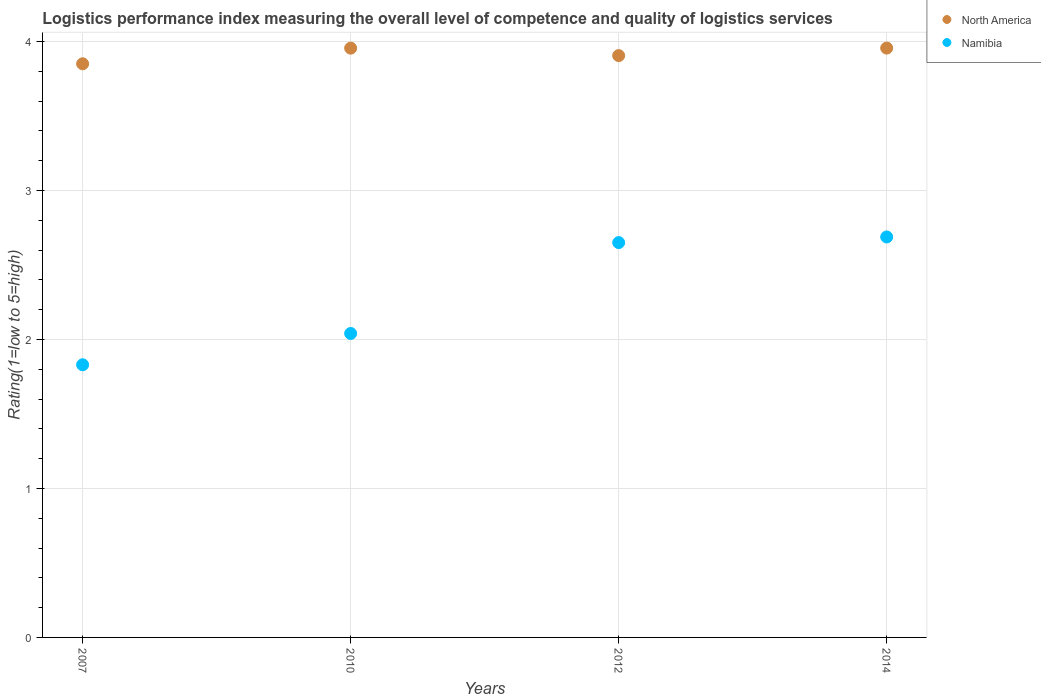What is the Logistic performance index in Namibia in 2012?
Your response must be concise. 2.65. Across all years, what is the maximum Logistic performance index in Namibia?
Make the answer very short. 2.69. Across all years, what is the minimum Logistic performance index in North America?
Offer a terse response. 3.85. What is the total Logistic performance index in Namibia in the graph?
Ensure brevity in your answer.  9.21. What is the difference between the Logistic performance index in Namibia in 2010 and that in 2014?
Offer a very short reply. -0.65. What is the difference between the Logistic performance index in North America in 2014 and the Logistic performance index in Namibia in 2007?
Make the answer very short. 2.13. What is the average Logistic performance index in North America per year?
Ensure brevity in your answer.  3.92. In the year 2010, what is the difference between the Logistic performance index in Namibia and Logistic performance index in North America?
Your answer should be compact. -1.92. What is the ratio of the Logistic performance index in Namibia in 2007 to that in 2010?
Offer a terse response. 0.9. Is the difference between the Logistic performance index in Namibia in 2012 and 2014 greater than the difference between the Logistic performance index in North America in 2012 and 2014?
Offer a very short reply. Yes. What is the difference between the highest and the second highest Logistic performance index in North America?
Make the answer very short. 0. What is the difference between the highest and the lowest Logistic performance index in Namibia?
Keep it short and to the point. 0.86. What is the difference between two consecutive major ticks on the Y-axis?
Provide a short and direct response. 1. Are the values on the major ticks of Y-axis written in scientific E-notation?
Your answer should be very brief. No. Does the graph contain grids?
Make the answer very short. Yes. Where does the legend appear in the graph?
Provide a short and direct response. Top right. What is the title of the graph?
Offer a terse response. Logistics performance index measuring the overall level of competence and quality of logistics services. Does "Jamaica" appear as one of the legend labels in the graph?
Your response must be concise. No. What is the label or title of the Y-axis?
Give a very brief answer. Rating(1=low to 5=high). What is the Rating(1=low to 5=high) of North America in 2007?
Make the answer very short. 3.85. What is the Rating(1=low to 5=high) in Namibia in 2007?
Offer a terse response. 1.83. What is the Rating(1=low to 5=high) in North America in 2010?
Give a very brief answer. 3.96. What is the Rating(1=low to 5=high) in Namibia in 2010?
Give a very brief answer. 2.04. What is the Rating(1=low to 5=high) of North America in 2012?
Provide a short and direct response. 3.9. What is the Rating(1=low to 5=high) in Namibia in 2012?
Give a very brief answer. 2.65. What is the Rating(1=low to 5=high) of North America in 2014?
Your response must be concise. 3.96. What is the Rating(1=low to 5=high) in Namibia in 2014?
Offer a very short reply. 2.69. Across all years, what is the maximum Rating(1=low to 5=high) in North America?
Give a very brief answer. 3.96. Across all years, what is the maximum Rating(1=low to 5=high) of Namibia?
Provide a succinct answer. 2.69. Across all years, what is the minimum Rating(1=low to 5=high) in North America?
Offer a terse response. 3.85. Across all years, what is the minimum Rating(1=low to 5=high) of Namibia?
Your answer should be very brief. 1.83. What is the total Rating(1=low to 5=high) in North America in the graph?
Provide a short and direct response. 15.67. What is the total Rating(1=low to 5=high) of Namibia in the graph?
Provide a succinct answer. 9.21. What is the difference between the Rating(1=low to 5=high) in North America in 2007 and that in 2010?
Your response must be concise. -0.1. What is the difference between the Rating(1=low to 5=high) of Namibia in 2007 and that in 2010?
Provide a short and direct response. -0.21. What is the difference between the Rating(1=low to 5=high) in North America in 2007 and that in 2012?
Keep it short and to the point. -0.06. What is the difference between the Rating(1=low to 5=high) in Namibia in 2007 and that in 2012?
Your answer should be compact. -0.82. What is the difference between the Rating(1=low to 5=high) of North America in 2007 and that in 2014?
Your answer should be compact. -0.11. What is the difference between the Rating(1=low to 5=high) in Namibia in 2007 and that in 2014?
Offer a terse response. -0.86. What is the difference between the Rating(1=low to 5=high) of North America in 2010 and that in 2012?
Give a very brief answer. 0.05. What is the difference between the Rating(1=low to 5=high) in Namibia in 2010 and that in 2012?
Give a very brief answer. -0.61. What is the difference between the Rating(1=low to 5=high) in North America in 2010 and that in 2014?
Give a very brief answer. -0. What is the difference between the Rating(1=low to 5=high) of Namibia in 2010 and that in 2014?
Keep it short and to the point. -0.65. What is the difference between the Rating(1=low to 5=high) in North America in 2012 and that in 2014?
Your answer should be compact. -0.05. What is the difference between the Rating(1=low to 5=high) of Namibia in 2012 and that in 2014?
Your answer should be compact. -0.04. What is the difference between the Rating(1=low to 5=high) in North America in 2007 and the Rating(1=low to 5=high) in Namibia in 2010?
Offer a very short reply. 1.81. What is the difference between the Rating(1=low to 5=high) of North America in 2007 and the Rating(1=low to 5=high) of Namibia in 2012?
Provide a succinct answer. 1.2. What is the difference between the Rating(1=low to 5=high) in North America in 2007 and the Rating(1=low to 5=high) in Namibia in 2014?
Your response must be concise. 1.16. What is the difference between the Rating(1=low to 5=high) in North America in 2010 and the Rating(1=low to 5=high) in Namibia in 2012?
Keep it short and to the point. 1.3. What is the difference between the Rating(1=low to 5=high) in North America in 2010 and the Rating(1=low to 5=high) in Namibia in 2014?
Offer a very short reply. 1.27. What is the difference between the Rating(1=low to 5=high) in North America in 2012 and the Rating(1=low to 5=high) in Namibia in 2014?
Offer a very short reply. 1.22. What is the average Rating(1=low to 5=high) in North America per year?
Ensure brevity in your answer.  3.92. What is the average Rating(1=low to 5=high) of Namibia per year?
Your answer should be compact. 2.3. In the year 2007, what is the difference between the Rating(1=low to 5=high) in North America and Rating(1=low to 5=high) in Namibia?
Offer a very short reply. 2.02. In the year 2010, what is the difference between the Rating(1=low to 5=high) in North America and Rating(1=low to 5=high) in Namibia?
Provide a succinct answer. 1.92. In the year 2012, what is the difference between the Rating(1=low to 5=high) in North America and Rating(1=low to 5=high) in Namibia?
Keep it short and to the point. 1.25. In the year 2014, what is the difference between the Rating(1=low to 5=high) of North America and Rating(1=low to 5=high) of Namibia?
Provide a succinct answer. 1.27. What is the ratio of the Rating(1=low to 5=high) in North America in 2007 to that in 2010?
Your response must be concise. 0.97. What is the ratio of the Rating(1=low to 5=high) of Namibia in 2007 to that in 2010?
Your answer should be very brief. 0.9. What is the ratio of the Rating(1=low to 5=high) in North America in 2007 to that in 2012?
Provide a succinct answer. 0.99. What is the ratio of the Rating(1=low to 5=high) of Namibia in 2007 to that in 2012?
Give a very brief answer. 0.69. What is the ratio of the Rating(1=low to 5=high) in North America in 2007 to that in 2014?
Give a very brief answer. 0.97. What is the ratio of the Rating(1=low to 5=high) in Namibia in 2007 to that in 2014?
Offer a very short reply. 0.68. What is the ratio of the Rating(1=low to 5=high) of North America in 2010 to that in 2012?
Your answer should be compact. 1.01. What is the ratio of the Rating(1=low to 5=high) in Namibia in 2010 to that in 2012?
Make the answer very short. 0.77. What is the ratio of the Rating(1=low to 5=high) of Namibia in 2010 to that in 2014?
Your answer should be compact. 0.76. What is the ratio of the Rating(1=low to 5=high) in North America in 2012 to that in 2014?
Provide a succinct answer. 0.99. What is the ratio of the Rating(1=low to 5=high) in Namibia in 2012 to that in 2014?
Make the answer very short. 0.99. What is the difference between the highest and the second highest Rating(1=low to 5=high) in North America?
Keep it short and to the point. 0. What is the difference between the highest and the second highest Rating(1=low to 5=high) of Namibia?
Your answer should be very brief. 0.04. What is the difference between the highest and the lowest Rating(1=low to 5=high) in North America?
Offer a very short reply. 0.11. What is the difference between the highest and the lowest Rating(1=low to 5=high) in Namibia?
Your answer should be very brief. 0.86. 